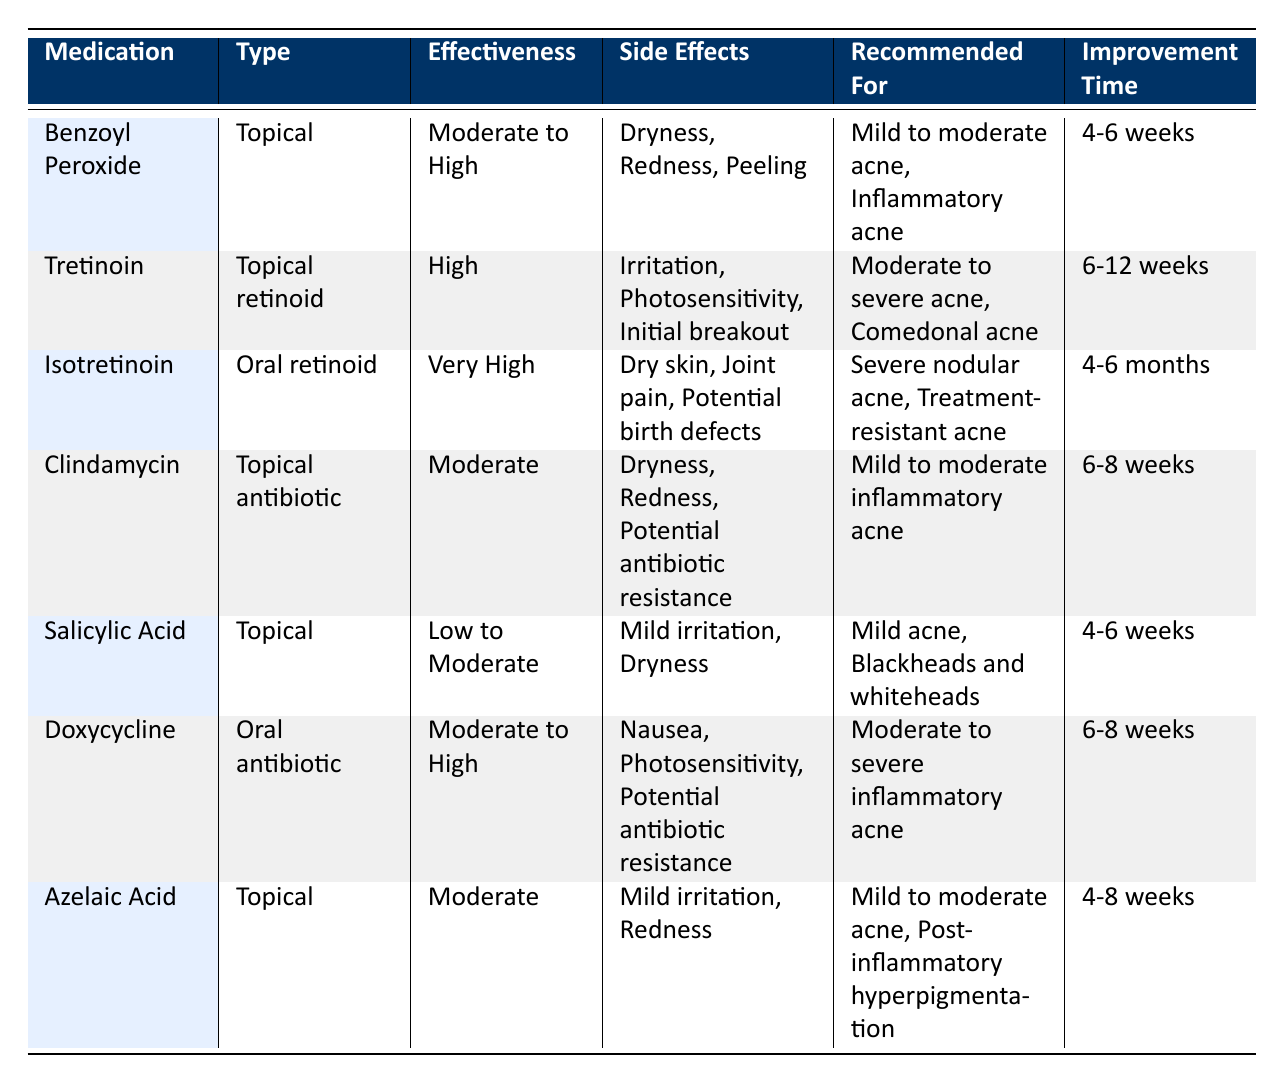What is the effectiveness level of Isotretinoin? The table lists the effectiveness of Isotretinoin as "Very High."
Answer: Very High Which medication requires a prescription? By examining the table, I can see that Tretinoin, Isotretinoin, Clindamycin, Doxycycline all have "true" in the Prescription Required column.
Answer: Tretinoin, Isotretinoin, Clindamycin, Doxycycline What are the typical improvement times for topical medications? By filtering the table, I find that the topical medications Benzoyl Peroxide, Tretinoin, Clindamycin, Salicylic Acid, and Azelaic Acid have typical improvement times of 4-6 weeks, 6-12 weeks, 6-8 weeks, 4-6 weeks, and 4-8 weeks respectively.
Answer: 4-12 weeks combined Is the side effect of Joint pain associated with any medication? The table indicates that Joint pain is listed as a side effect for Isotretinoin only, confirming it exists for that medication.
Answer: Yes, Isotretinoin What is the difference in typical improvement time between the most and least effective medications? The least effective is Salicylic Acid or Azelaic Acid (4-6 weeks improvement), while the most effective is Isotretinoin (4-6 months or 16-24 weeks). The difference is 24 weeks - 6 weeks = 18 weeks.
Answer: 18 weeks What medications are recommended for mild to moderate acne? By scanning through the recommended for column, I can identify that Benzoyl Peroxide, Clindamycin, and Azelaic Acid are recommended for mild to moderate acne.
Answer: Benzoyl Peroxide, Clindamycin, Azelaic Acid 